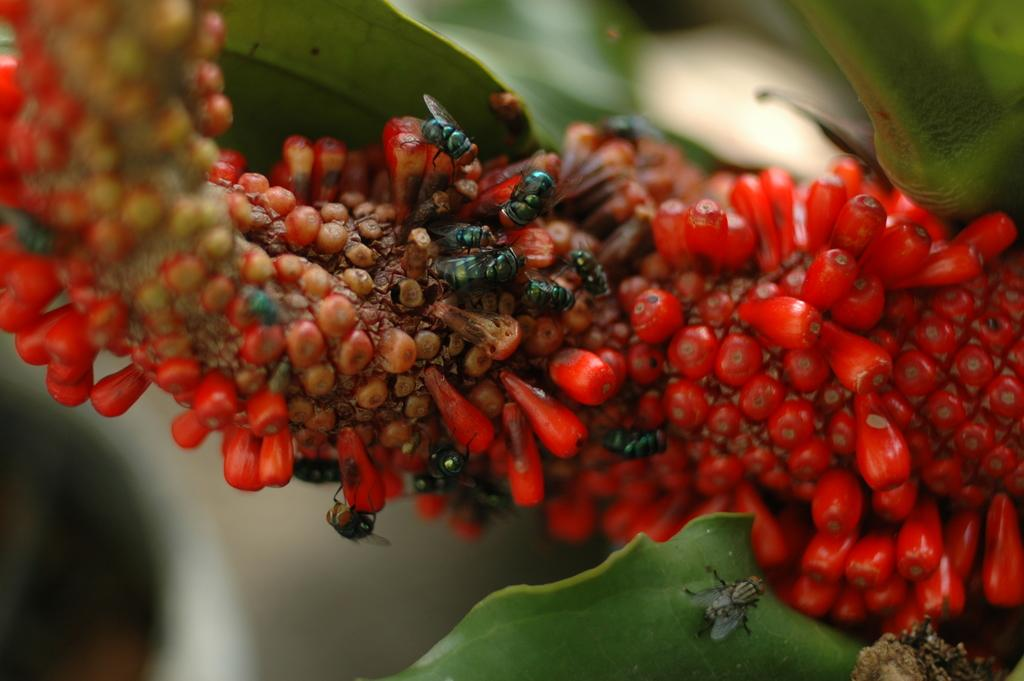What type of plant is in the image? The plant in the image has red color fruits. What are the fruits on the plant? The fruits on the plant are red. Are there any insects present on the plant? Yes, house flies are present on the plant. What are the house flies doing on the plant? The house flies are eating the fruits on the plant. What else is associated with the plant? There are leaves associated with the plant. What type of kite can be seen flying near the mountain in the image? There is no kite or mountain present in the image; it features a plant with red fruits and house flies. What invention is being used to harvest the fruits on the plant in the image? There is no invention depicted in the image; the house flies are eating the fruits on the plant. 